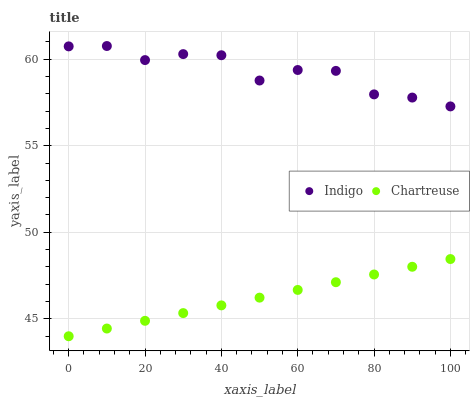Does Chartreuse have the minimum area under the curve?
Answer yes or no. Yes. Does Indigo have the maximum area under the curve?
Answer yes or no. Yes. Does Indigo have the minimum area under the curve?
Answer yes or no. No. Is Chartreuse the smoothest?
Answer yes or no. Yes. Is Indigo the roughest?
Answer yes or no. Yes. Is Indigo the smoothest?
Answer yes or no. No. Does Chartreuse have the lowest value?
Answer yes or no. Yes. Does Indigo have the lowest value?
Answer yes or no. No. Does Indigo have the highest value?
Answer yes or no. Yes. Is Chartreuse less than Indigo?
Answer yes or no. Yes. Is Indigo greater than Chartreuse?
Answer yes or no. Yes. Does Chartreuse intersect Indigo?
Answer yes or no. No. 